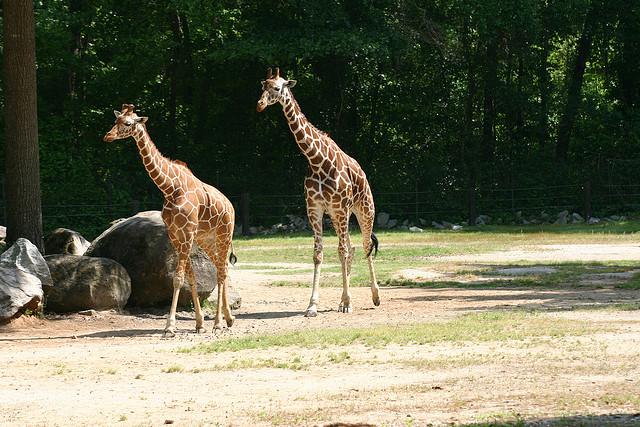Are there any animals?
Give a very brief answer. Yes. Is the taller giraffe standing nearest the rocks?
Be succinct. No. How many giraffes are there?
Concise answer only. 2. 